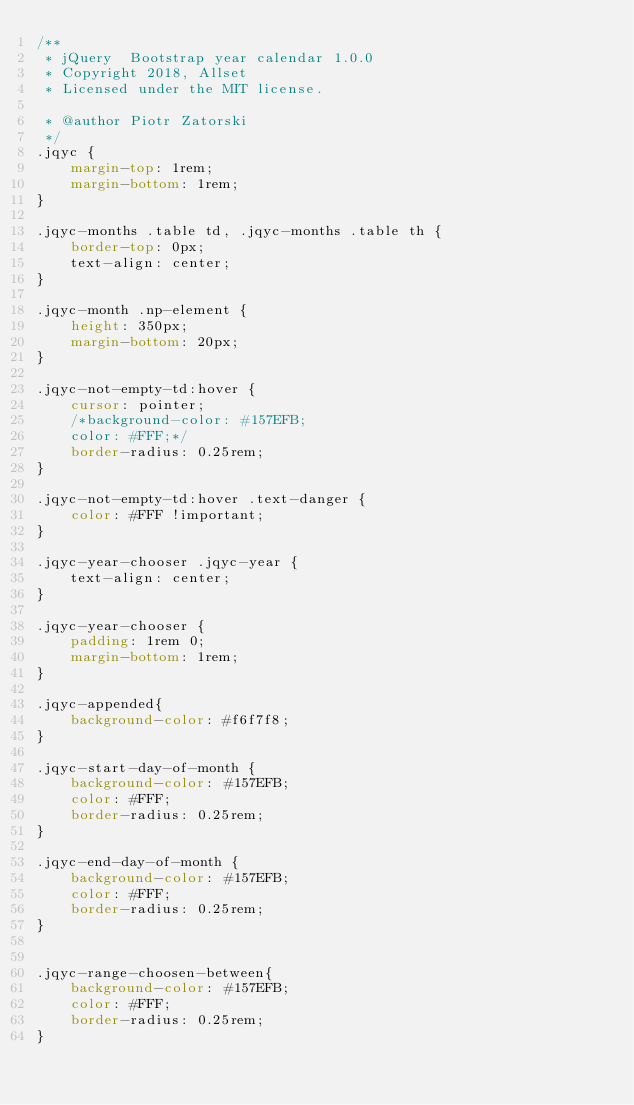Convert code to text. <code><loc_0><loc_0><loc_500><loc_500><_CSS_>/**
 * jQuery  Bootstrap year calendar 1.0.0
 * Copyright 2018, Allset
 * Licensed under the MIT license.

 * @author Piotr Zatorski
 */
.jqyc {
    margin-top: 1rem;
    margin-bottom: 1rem;
}

.jqyc-months .table td, .jqyc-months .table th {
    border-top: 0px;
    text-align: center;
}

.jqyc-month .np-element {
    height: 350px;
    margin-bottom: 20px;
}

.jqyc-not-empty-td:hover {
    cursor: pointer;
    /*background-color: #157EFB;
    color: #FFF;*/
    border-radius: 0.25rem;
}

.jqyc-not-empty-td:hover .text-danger {
    color: #FFF !important;
}

.jqyc-year-chooser .jqyc-year {
    text-align: center;
}

.jqyc-year-chooser {
    padding: 1rem 0;
    margin-bottom: 1rem;
}

.jqyc-appended{
    background-color: #f6f7f8;
}

.jqyc-start-day-of-month {
    background-color: #157EFB;
    color: #FFF;
    border-radius: 0.25rem;
}

.jqyc-end-day-of-month {
    background-color: #157EFB;
    color: #FFF;
    border-radius: 0.25rem;
}


.jqyc-range-choosen-between{
    background-color: #157EFB;
    color: #FFF;
    border-radius: 0.25rem;
}
</code> 